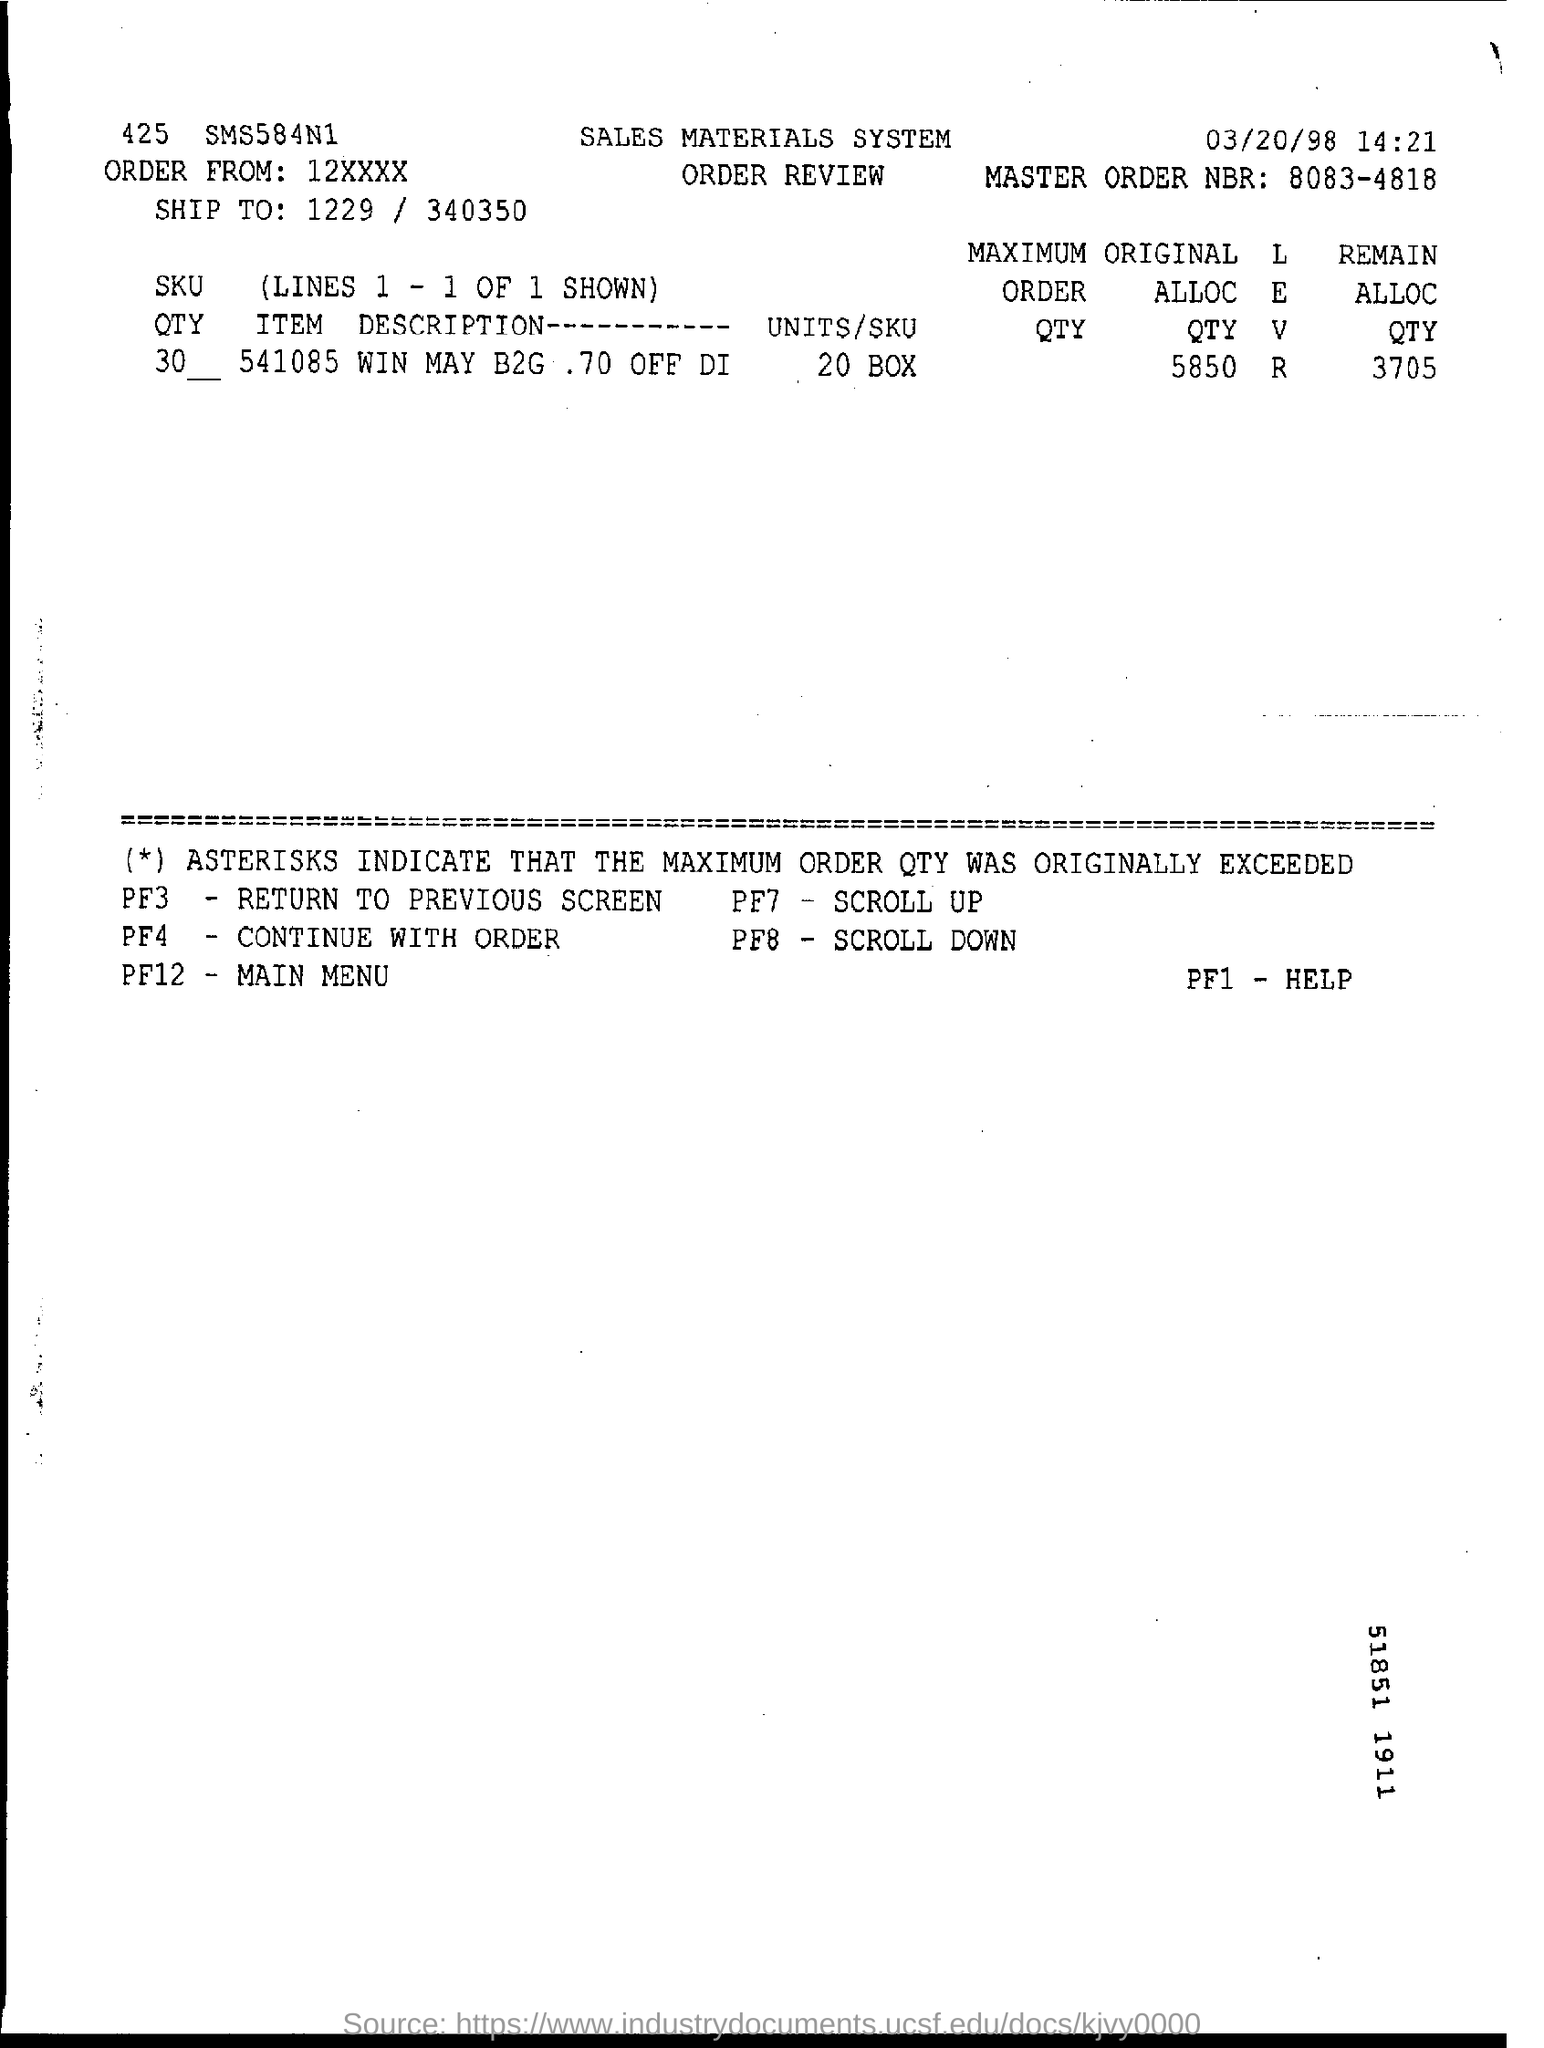Indicate a few pertinent items in this graphic. Can you please provide the master order number? It is 8083-4818. What is the remaining allocation quantity? It is 3,705. 